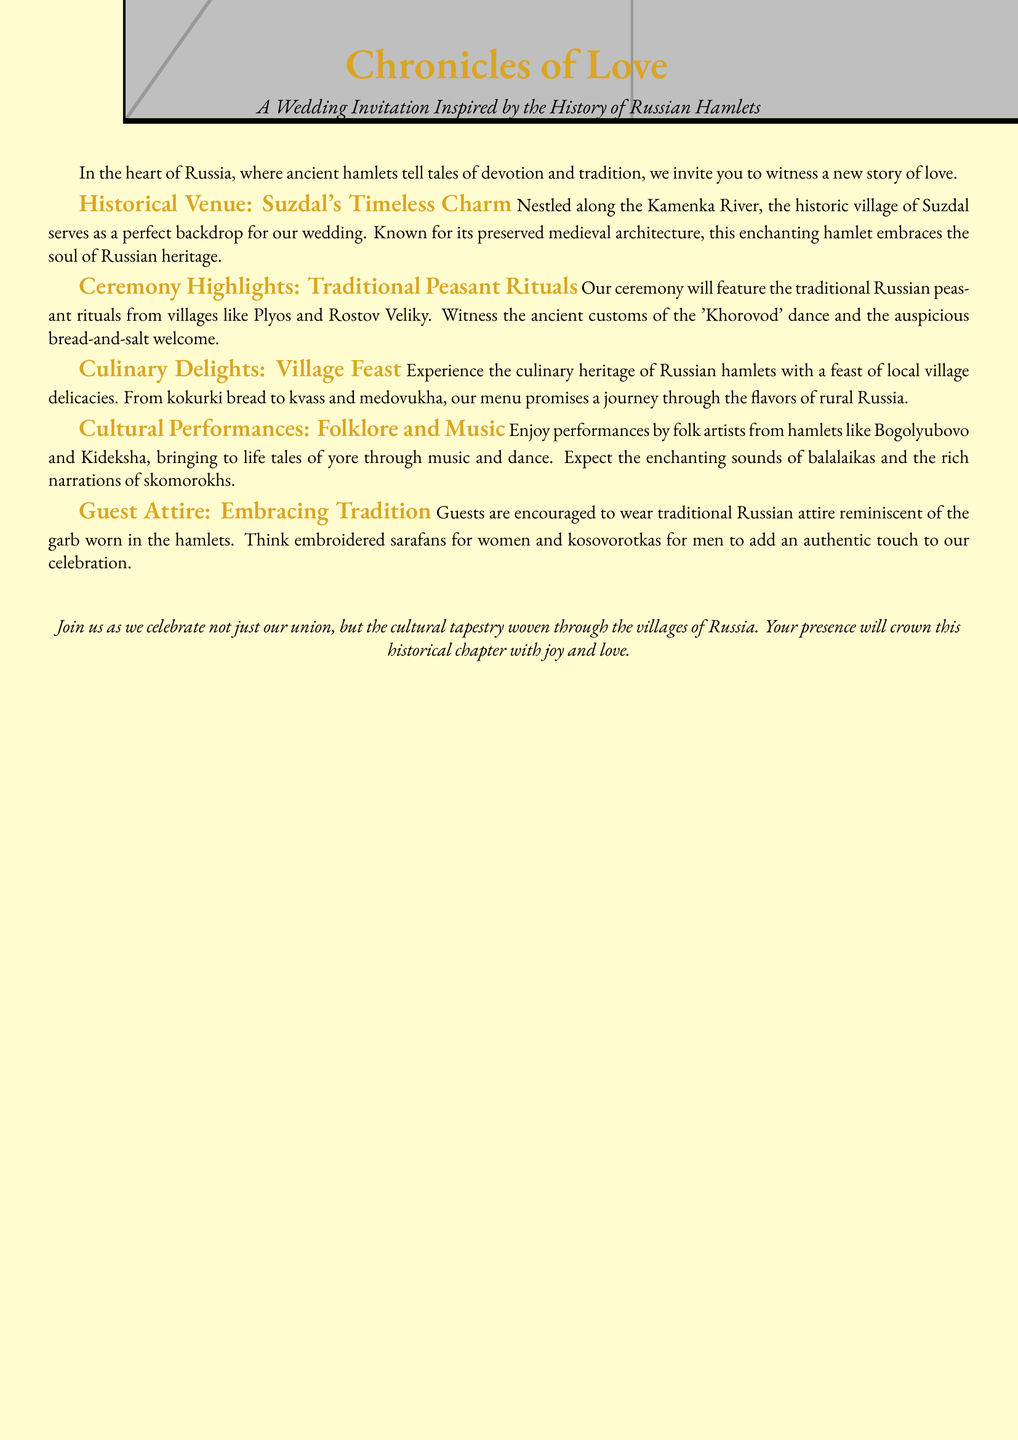What is the title of the wedding invitation? The title is prominently displayed at the top of the document, indicating the theme of the wedding.
Answer: Chronicles of Love Where is the historical venue located? The document specifies the location of the venue in relation to significant landmarks in Russia.
Answer: Suzdal What dance will be featured in the ceremony? The document mentions a specific traditional dance associated with the wedding rituals.
Answer: Khorovod What types of food will be served at the wedding feast? The document lists specific foods that represent the culinary heritage of Russian villages.
Answer: Village delicacies Which musical instruments will be featured in the cultural performances? The document highlights certain instruments that are traditionally used in folk performances.
Answer: Balalaikas What is encouraged for guest attire? The document suggests a specific type of clothing that guests should wear to reflect the cultural theme.
Answer: Traditional Russian attire From which regions will the performers come? The document mentions specific villages where the performing artists are from.
Answer: Bogolyubovo and Kideksha What do the organizers invite guests to celebrate? The document emphasizes the broader significance of attending the wedding beyond the couple.
Answer: Cultural tapestry How is the wedding invitation visually styled? The document describes the overall aesthetic presentation and style used for the invitation.
Answer: Inspired by the history of Russian hamlets 